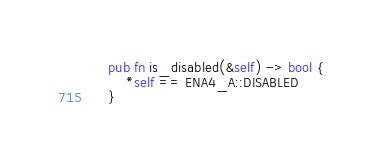Convert code to text. <code><loc_0><loc_0><loc_500><loc_500><_Rust_>    pub fn is_disabled(&self) -> bool {
        *self == ENA4_A::DISABLED
    }</code> 